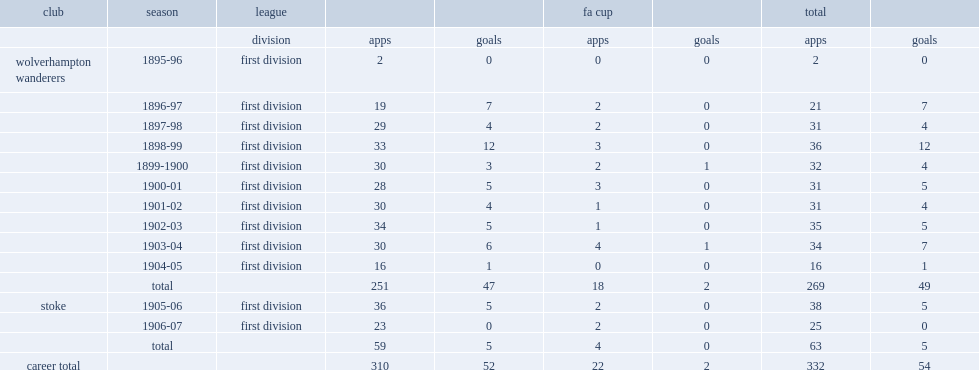How many goals did miller score for wolves totally? 49.0. 